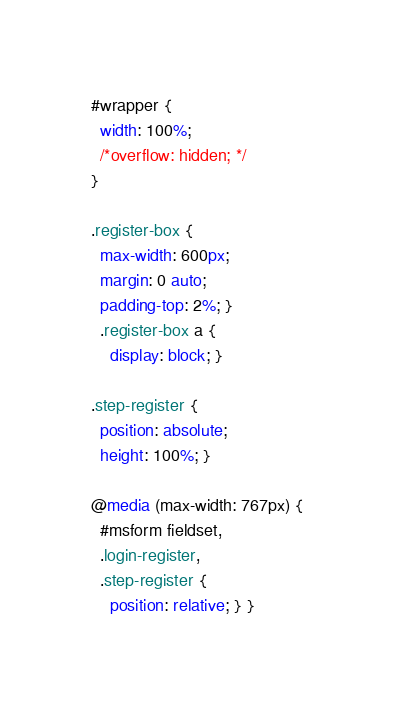<code> <loc_0><loc_0><loc_500><loc_500><_CSS_>#wrapper {
  width: 100%;
  /*overflow: hidden; */
}

.register-box {
  max-width: 600px;
  margin: 0 auto;
  padding-top: 2%; }
  .register-box a {
    display: block; }

.step-register {
  position: absolute;
  height: 100%; }

@media (max-width: 767px) {
  #msform fieldset,
  .login-register,
  .step-register {
    position: relative; } }
</code> 